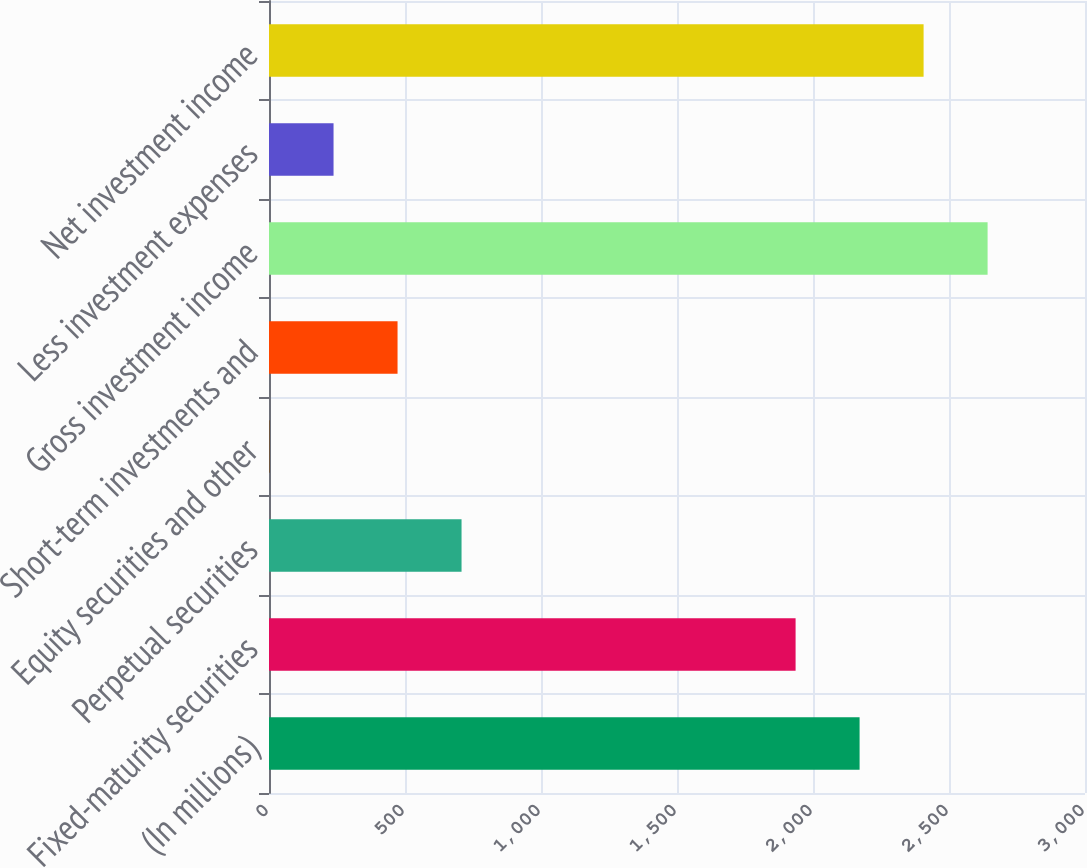<chart> <loc_0><loc_0><loc_500><loc_500><bar_chart><fcel>(In millions)<fcel>Fixed-maturity securities<fcel>Perpetual securities<fcel>Equity securities and other<fcel>Short-term investments and<fcel>Gross investment income<fcel>Less investment expenses<fcel>Net investment income<nl><fcel>2171.3<fcel>1936<fcel>707.9<fcel>2<fcel>472.6<fcel>2641.9<fcel>237.3<fcel>2406.6<nl></chart> 